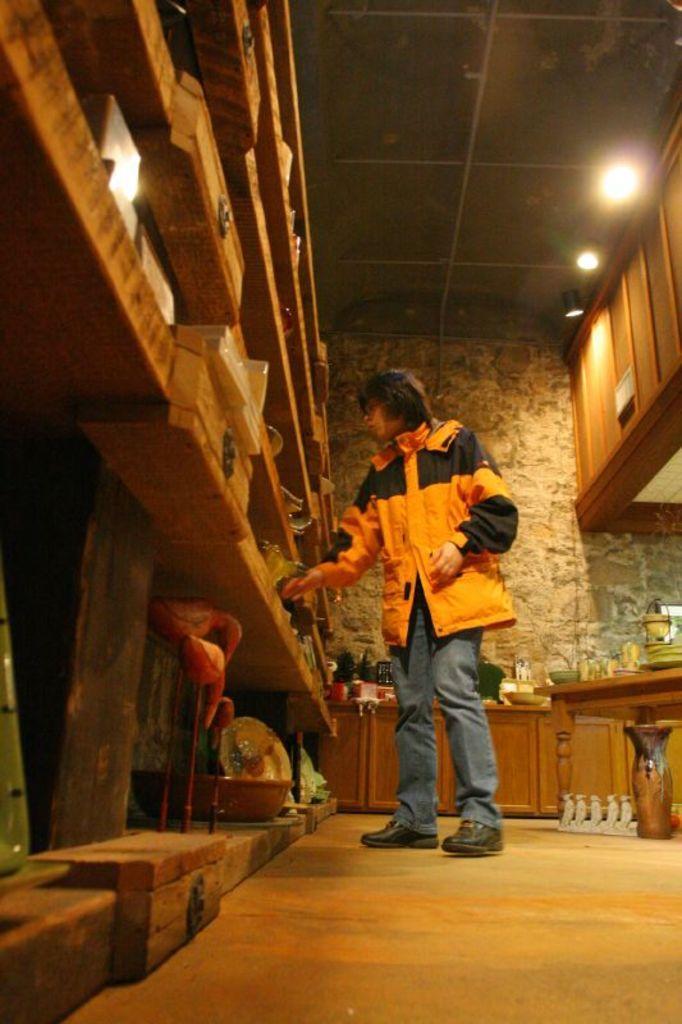Describe this image in one or two sentences. In this image there is a person in the middle. In front of her there are wooden racks. At the top there are lights. Under the lights there are cupboards. On the floor there is a pot on the right side. In the background there is a platform on which there are bowls and jars. 